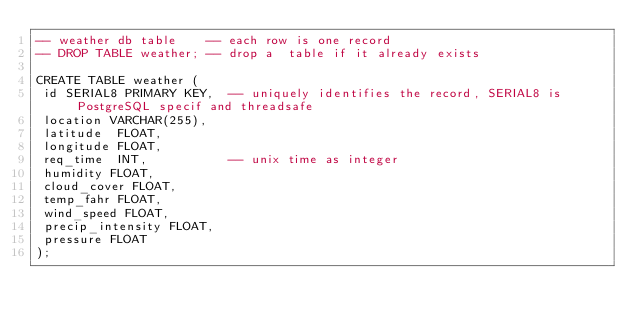Convert code to text. <code><loc_0><loc_0><loc_500><loc_500><_SQL_>-- weather db table    -- each row is one record
-- DROP TABLE weather; -- drop a  table if it already exists

CREATE TABLE weather (
 id SERIAL8 PRIMARY KEY,  -- uniquely identifies the record, SERIAL8 is PostgreSQL specif and threadsafe
 location VARCHAR(255),
 latitude  FLOAT,
 longitude FLOAT,
 req_time  INT,           -- unix time as integer
 humidity FLOAT,
 cloud_cover FLOAT,
 temp_fahr FLOAT,
 wind_speed FLOAT,
 precip_intensity FLOAT,
 pressure FLOAT
); 
</code> 